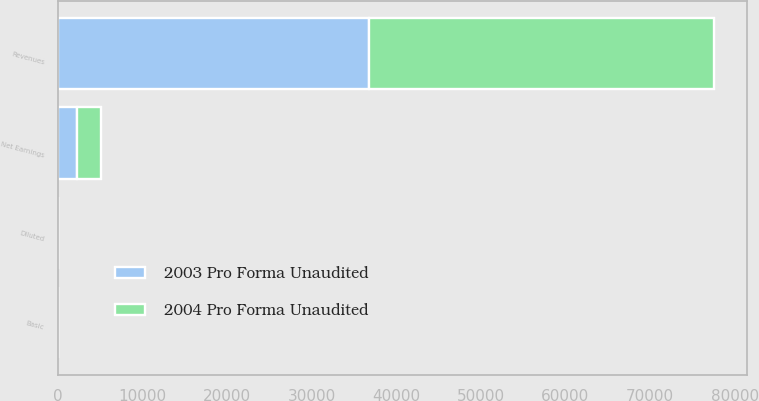<chart> <loc_0><loc_0><loc_500><loc_500><stacked_bar_chart><ecel><fcel>Revenues<fcel>Net Earnings<fcel>Basic<fcel>Diluted<nl><fcel>2004 Pro Forma Unaudited<fcel>40773<fcel>2776<fcel>4.21<fcel>4.03<nl><fcel>2003 Pro Forma Unaudited<fcel>36809<fcel>2257<fcel>3.33<fcel>3.19<nl></chart> 